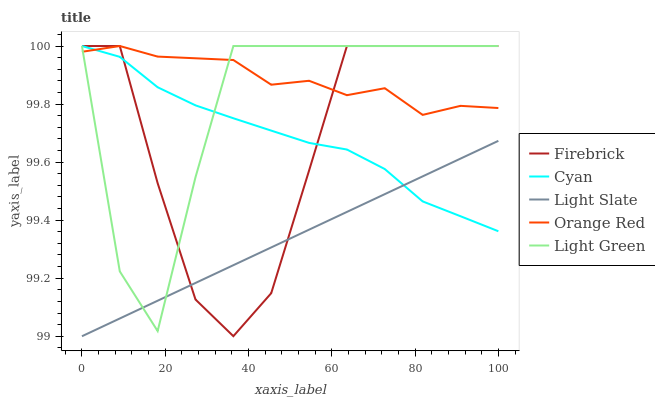Does Cyan have the minimum area under the curve?
Answer yes or no. No. Does Cyan have the maximum area under the curve?
Answer yes or no. No. Is Cyan the smoothest?
Answer yes or no. No. Is Cyan the roughest?
Answer yes or no. No. Does Cyan have the lowest value?
Answer yes or no. No. Is Light Slate less than Orange Red?
Answer yes or no. Yes. Is Orange Red greater than Light Slate?
Answer yes or no. Yes. Does Light Slate intersect Orange Red?
Answer yes or no. No. 